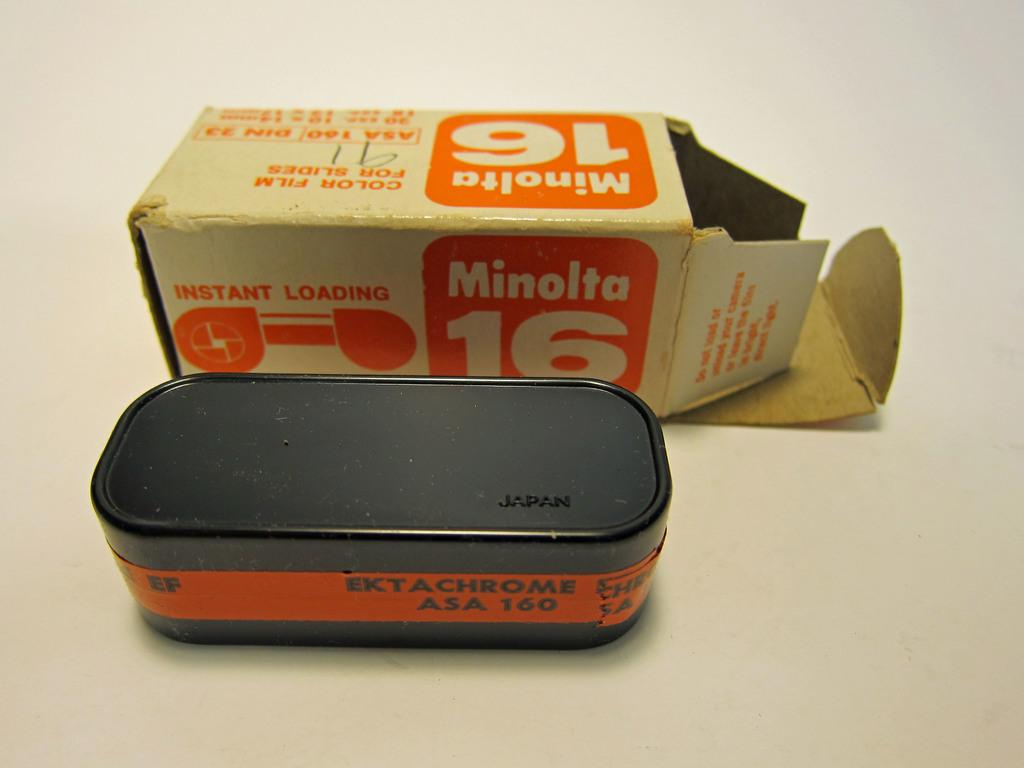<image>
Render a clear and concise summary of the photo. A canister of instant loading film from Minolta. 